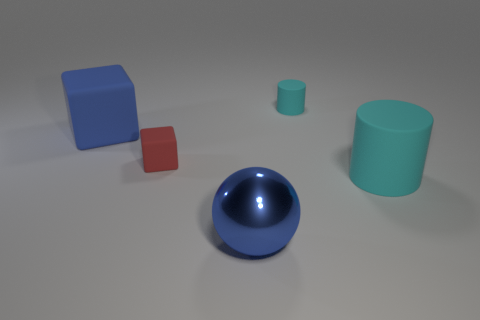Add 2 big blocks. How many objects exist? 7 Subtract all spheres. How many objects are left? 4 Subtract 0 purple cubes. How many objects are left? 5 Subtract all purple shiny cubes. Subtract all tiny red rubber blocks. How many objects are left? 4 Add 3 red things. How many red things are left? 4 Add 5 tiny matte cylinders. How many tiny matte cylinders exist? 6 